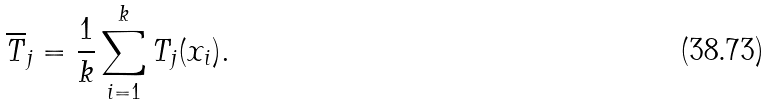Convert formula to latex. <formula><loc_0><loc_0><loc_500><loc_500>\overline { T } _ { j } = \frac { 1 } { k } \sum _ { i = 1 } ^ { k } T _ { j } ( x _ { i } ) .</formula> 